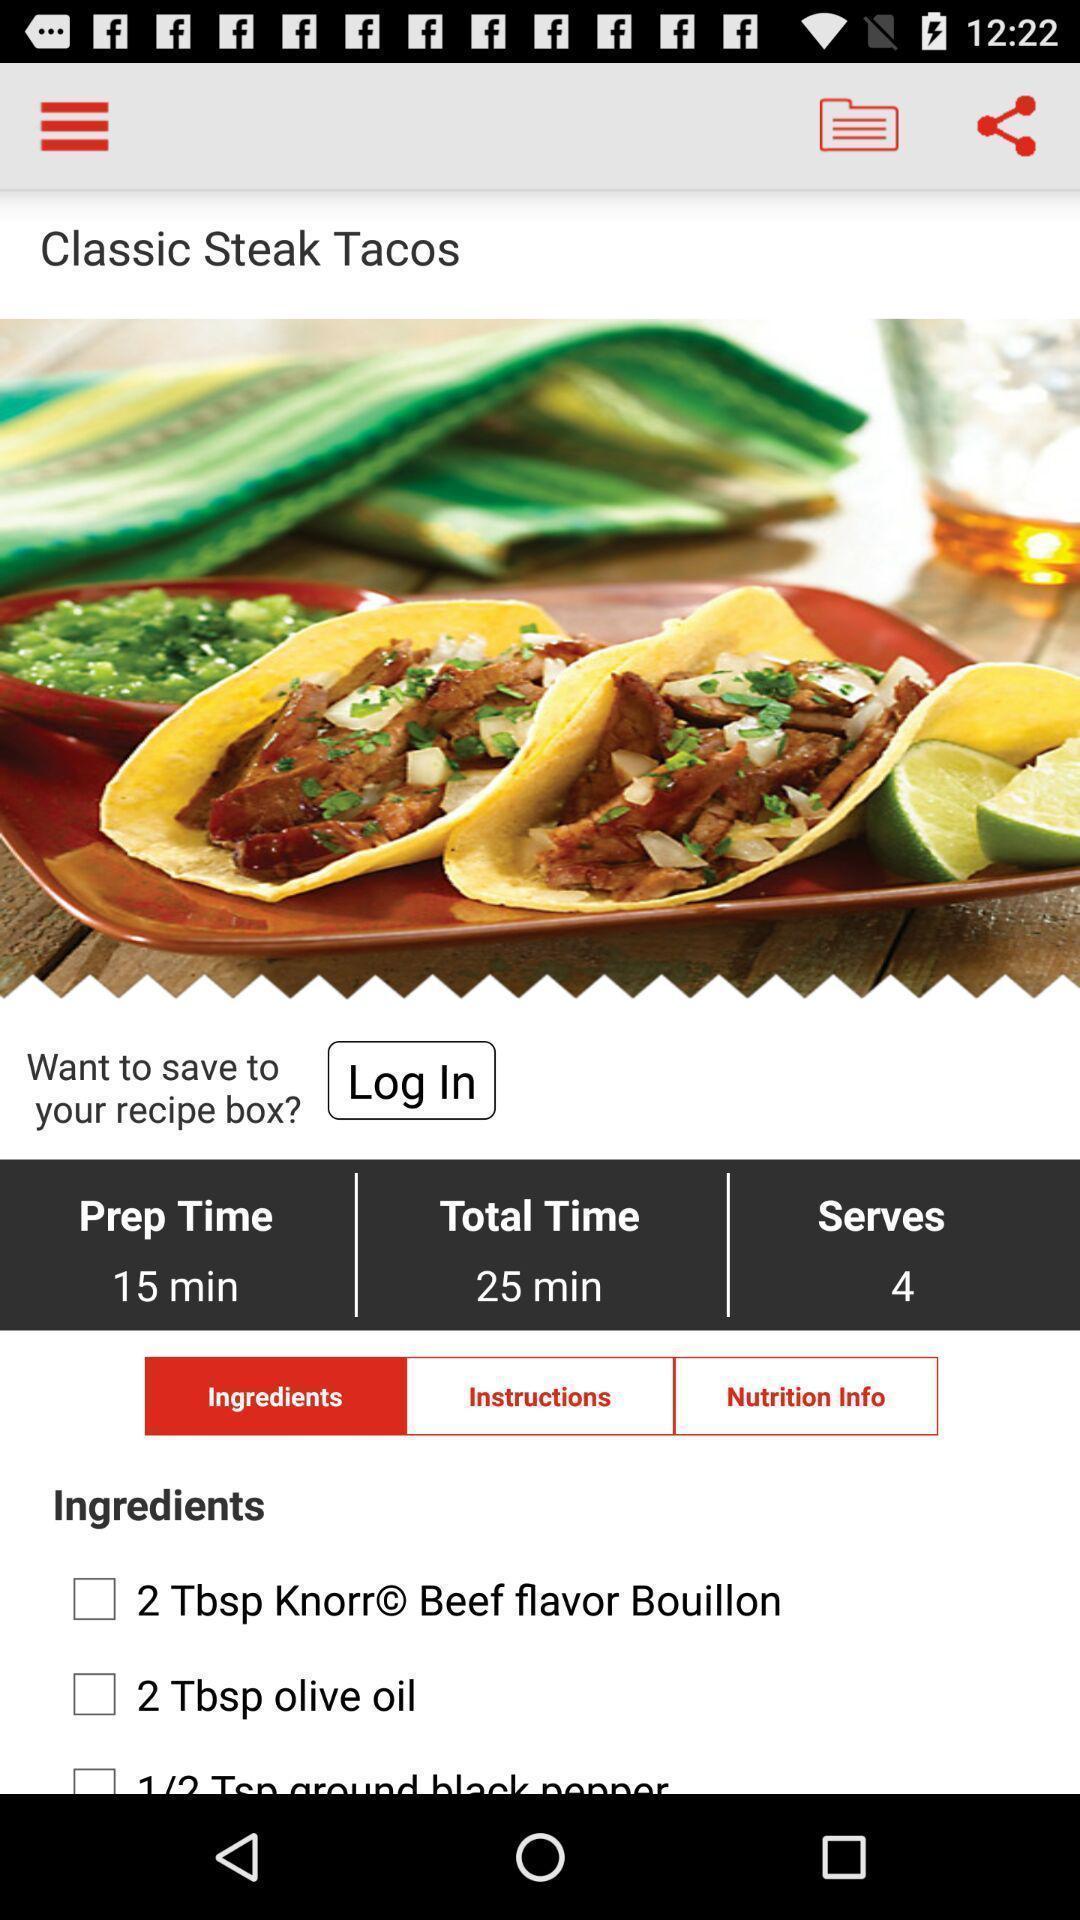What can you discern from this picture? Screen showing recipe details in cook book app. 